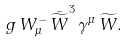Convert formula to latex. <formula><loc_0><loc_0><loc_500><loc_500>g \, W ^ { - } _ { \mu } \, \bar { \widetilde { W } } ^ { 3 } \, \gamma ^ { \mu } \, \widetilde { W } .</formula> 